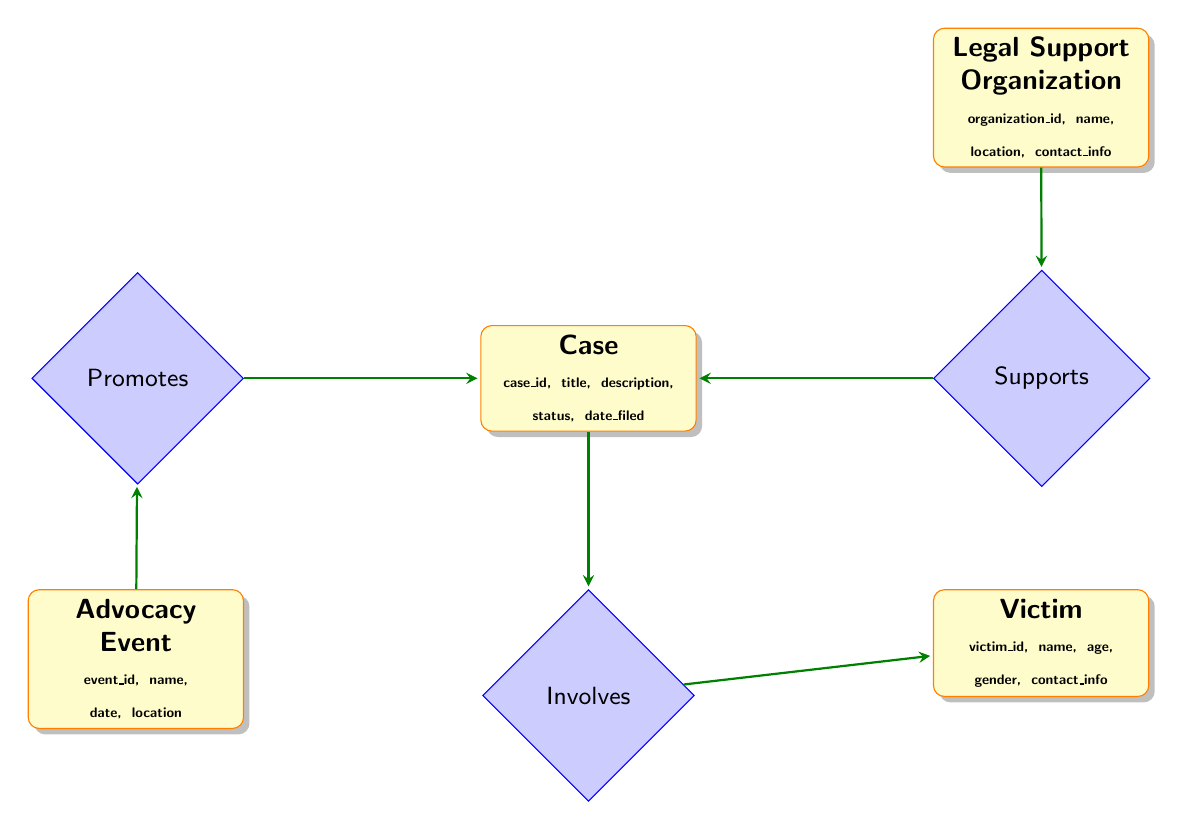What are the entities in the diagram? The diagram contains four entities: Case, Victim, Legal Support Organization, and Advocacy Event.
Answer: Case, Victim, Legal Support Organization, Advocacy Event How many attributes does the Victim entity have? The Victim entity has five attributes: victim_id, name, age, gender, and contact_info.
Answer: 5 What relationship exists between Legal Support Organization and Case? The relationship is called "Supports," indicating that a Legal Support Organization is involved in providing support for a Case.
Answer: Supports How many relationships are present in the diagram? There are three relationships in the diagram: Supports, Involves, and Promotes.
Answer: 3 Which entity is involved in the relationship "Involves"? The relationship "Involves" connects the Case entity to the Victim entity, indicating that a case involves a victim.
Answer: Victim What is the relationship between Advocacy Event and Case? The diagram shows that the Advocacy Event "Promotes" the Case, meaning that an event is aimed at raising awareness or support for a particular case.
Answer: Promotes What is the title of the fourth entity? The title of the fourth entity is Advocacy Event.
Answer: Advocacy Event Which entity is represented by case_id? The case_id is an attribute of the Case entity, which uniquely identifies each case.
Answer: Case 